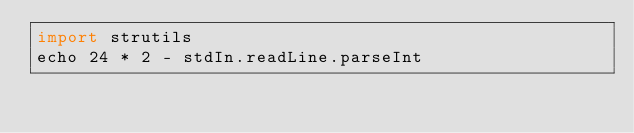<code> <loc_0><loc_0><loc_500><loc_500><_Nim_>import strutils
echo 24 * 2 - stdIn.readLine.parseInt</code> 